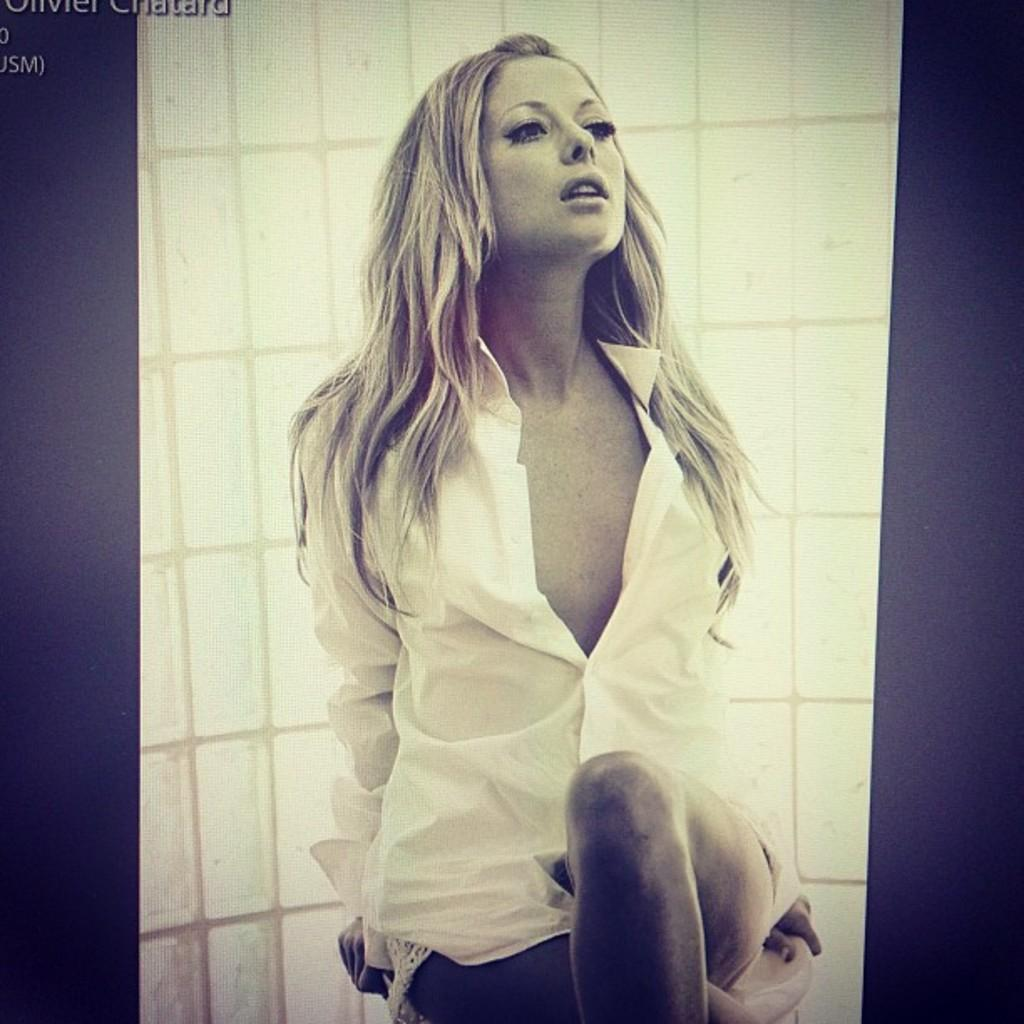What is the woman doing in the image? The woman is sitting in the image. What can be seen in the background of the image? There is a wall in the background of the image. Is there any text visible in the image? Yes, there is some text visible at the left top of the image. What type of linen is being used by the woman in the image? There is no linen visible in the image, and the woman's clothing or accessories are not described in the provided facts. 